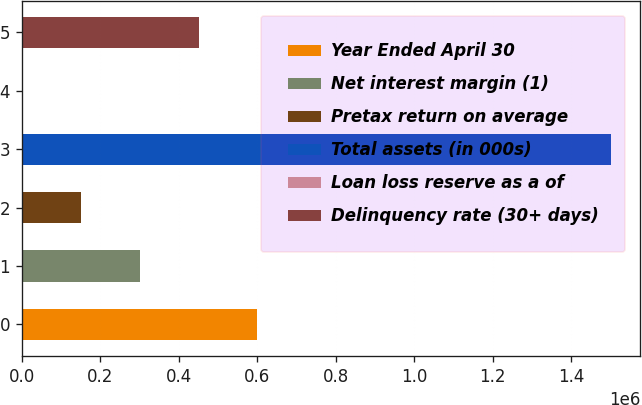Convert chart to OTSL. <chart><loc_0><loc_0><loc_500><loc_500><bar_chart><fcel>Year Ended April 30<fcel>Net interest margin (1)<fcel>Pretax return on average<fcel>Total assets (in 000s)<fcel>Loan loss reserve as a of<fcel>Delinquency rate (30+ days)<nl><fcel>600556<fcel>300278<fcel>150139<fcel>1.50139e+06<fcel>0.25<fcel>450417<nl></chart> 